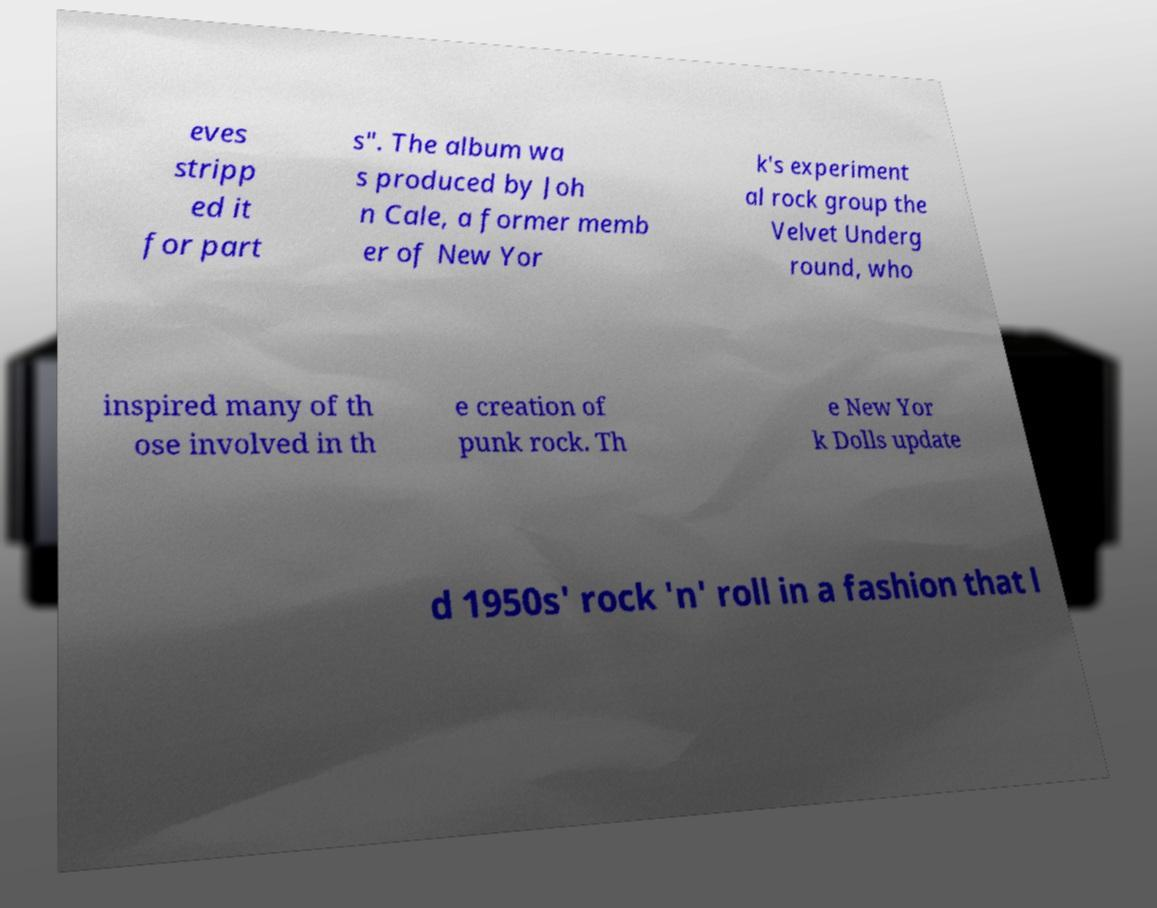Can you read and provide the text displayed in the image?This photo seems to have some interesting text. Can you extract and type it out for me? eves stripp ed it for part s". The album wa s produced by Joh n Cale, a former memb er of New Yor k's experiment al rock group the Velvet Underg round, who inspired many of th ose involved in th e creation of punk rock. Th e New Yor k Dolls update d 1950s' rock 'n' roll in a fashion that l 